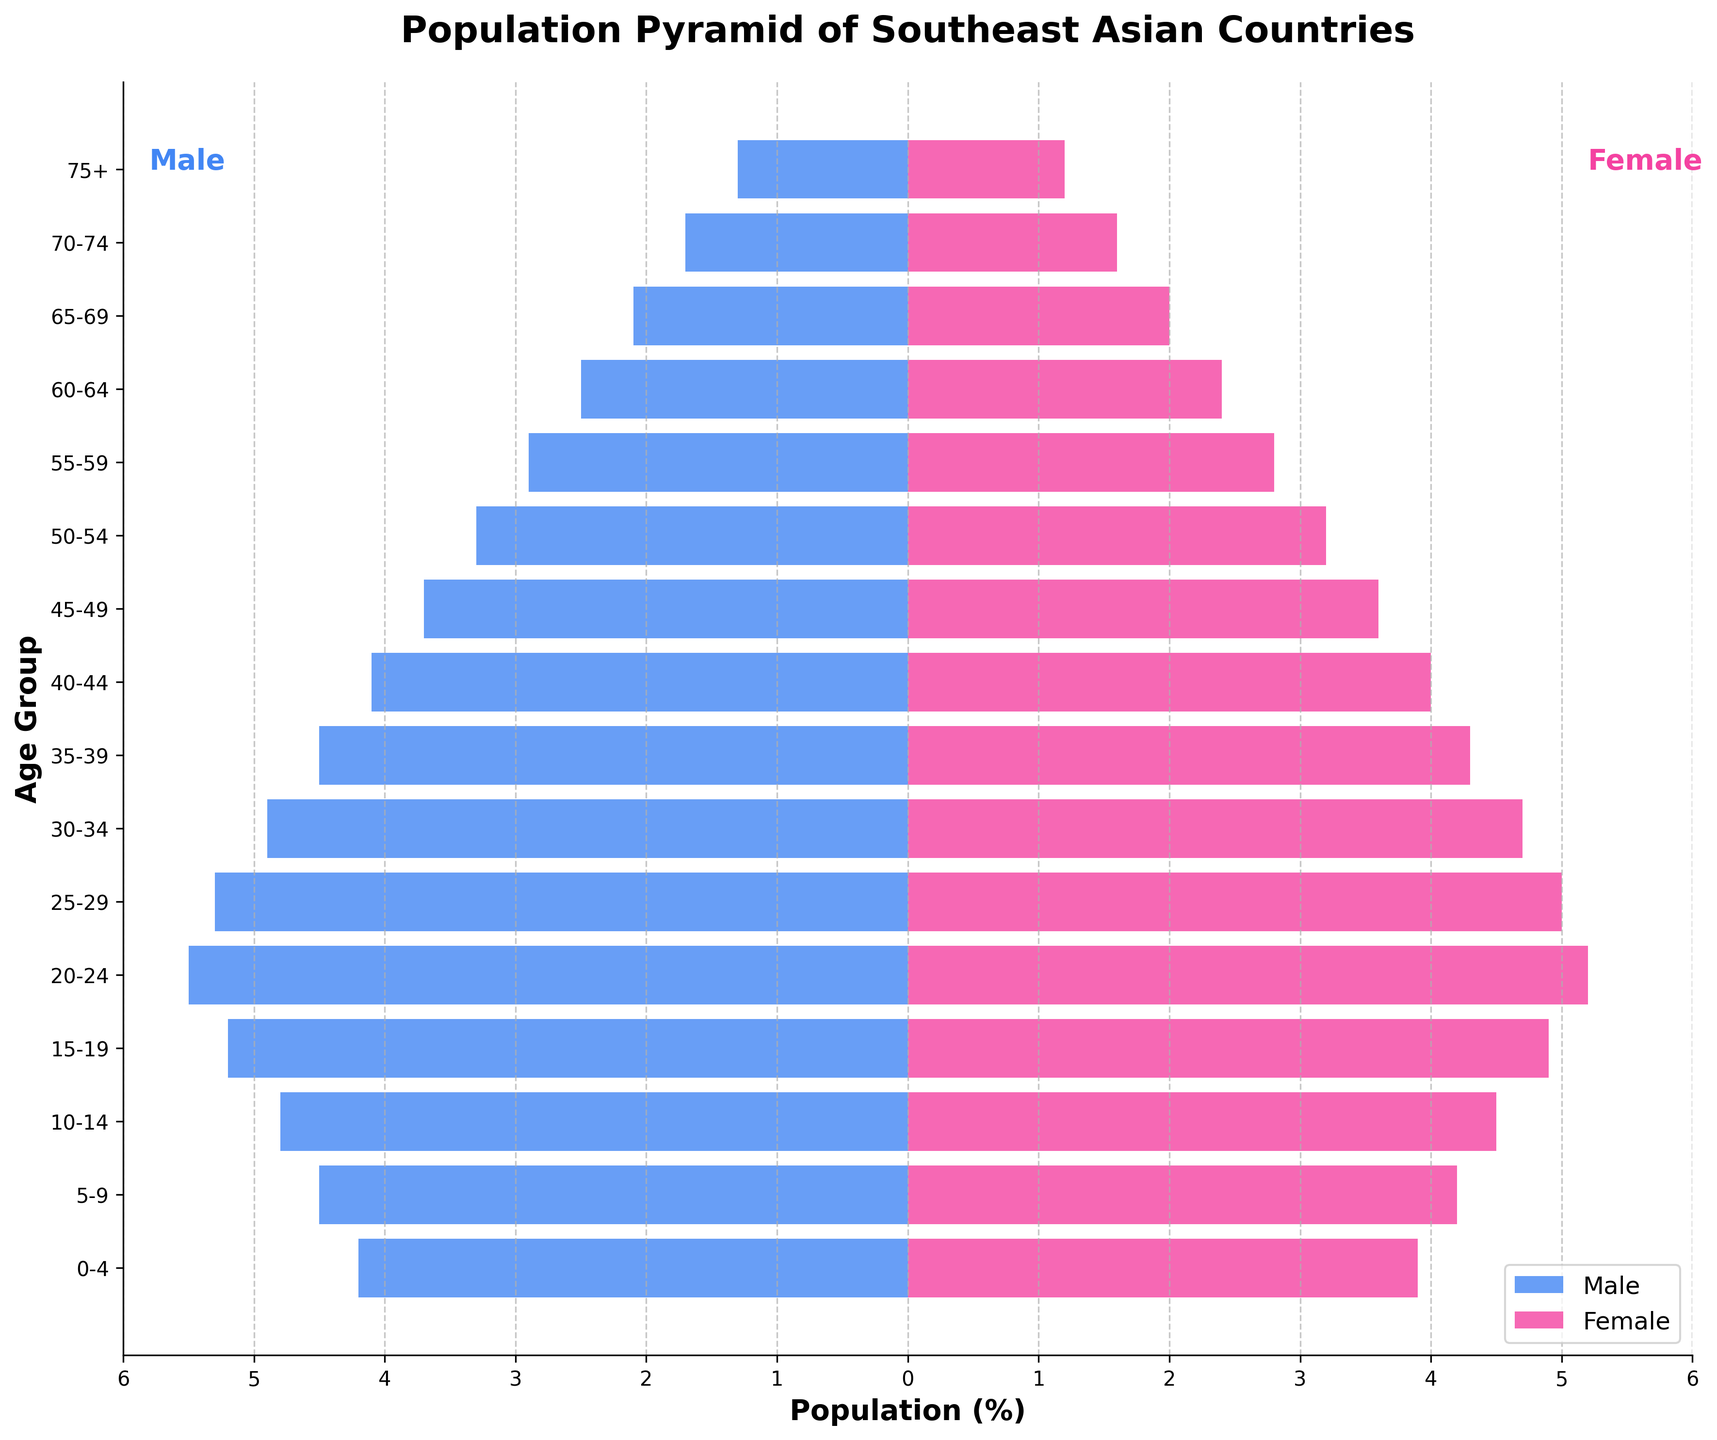What's the title of the figure? The title of the figure is prominently displayed at the top and reads "Population Pyramid of Southeast Asian Countries".
Answer: Population Pyramid of Southeast Asian Countries What age group has the highest population for males? The highest population for males is represented by the longest bar extending to the left side of the y-axis. This corresponds to the age group "20-24".
Answer: 20-24 What is the difference in population percentage between males and females in the age group 0-4? The population percentage of males in the age group 0-4 is 4.2% and for females, it is 3.9%. The difference is calculated as 4.2 - 3.9 = 0.3%.
Answer: 0.3% Which age group has the closest male and female population percentages? By inspecting the bars, the age group "45-49" has male and female percentages very close to each other, with 3.7% for males and 3.6% for females.
Answer: 45-49 In which age groups do females have a higher population percentage than males? By examining the lengths of the bars, females have a higher population percentage than males in the age groups "60-64" (2.5% males, 2.4% females) and "70-74" (1.7% males, 1.6% females).
Answer: 60-64, 70-74 What is the total population percentage of the age groups under 20 years for males? The population percentages of males in the age groups under 20 years are 4.2, 4.5, 4.8, and 5.2. Summing them up gives 4.2 + 4.5 + 4.8 + 5.2 = 18.7%.
Answer: 18.7% What can you infer about political implications based on the youth bulge in the figure? A significant percentage of the population is concentrated in the younger age groups (15-29), indicated by the longer bars for these ages. This youth bulge can lead to increased political instability if sufficient employment and economic opportunities are not provided, as youth may become frustrated.
Answer: Significant youth bulge suggests potential political instability due to lack of opportunities Compare the male and female populations in the age group 20-24. Which gender has a higher percentage and by how much? For the age group 20-24, males have a population percentage of 5.5% and females have 5.2%. The difference is 5.5 - 5.2 = 0.3%, where males have the higher percentage.
Answer: Males by 0.3% What is the range of population percentages observed in the figure? The lowest population percentage observed is 1.2% (females aged 75+), and the highest is 5.5% (males aged 20-24), giving a range of 5.5 - 1.2 = 4.3%.
Answer: 4.3% How does the population distribution change as age increases? The population percentages for both males and females generally decrease as the age groups increase, reflecting a typical population pyramid shape with more young people and fewer older individuals.
Answer: Decreases as age increases 